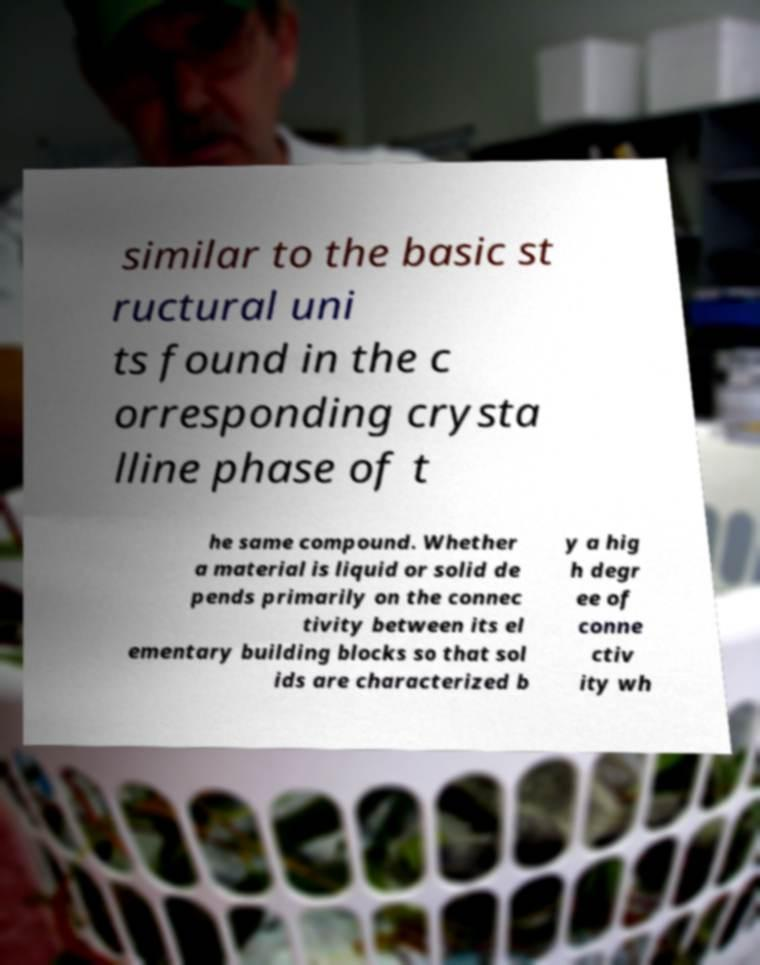Can you accurately transcribe the text from the provided image for me? similar to the basic st ructural uni ts found in the c orresponding crysta lline phase of t he same compound. Whether a material is liquid or solid de pends primarily on the connec tivity between its el ementary building blocks so that sol ids are characterized b y a hig h degr ee of conne ctiv ity wh 